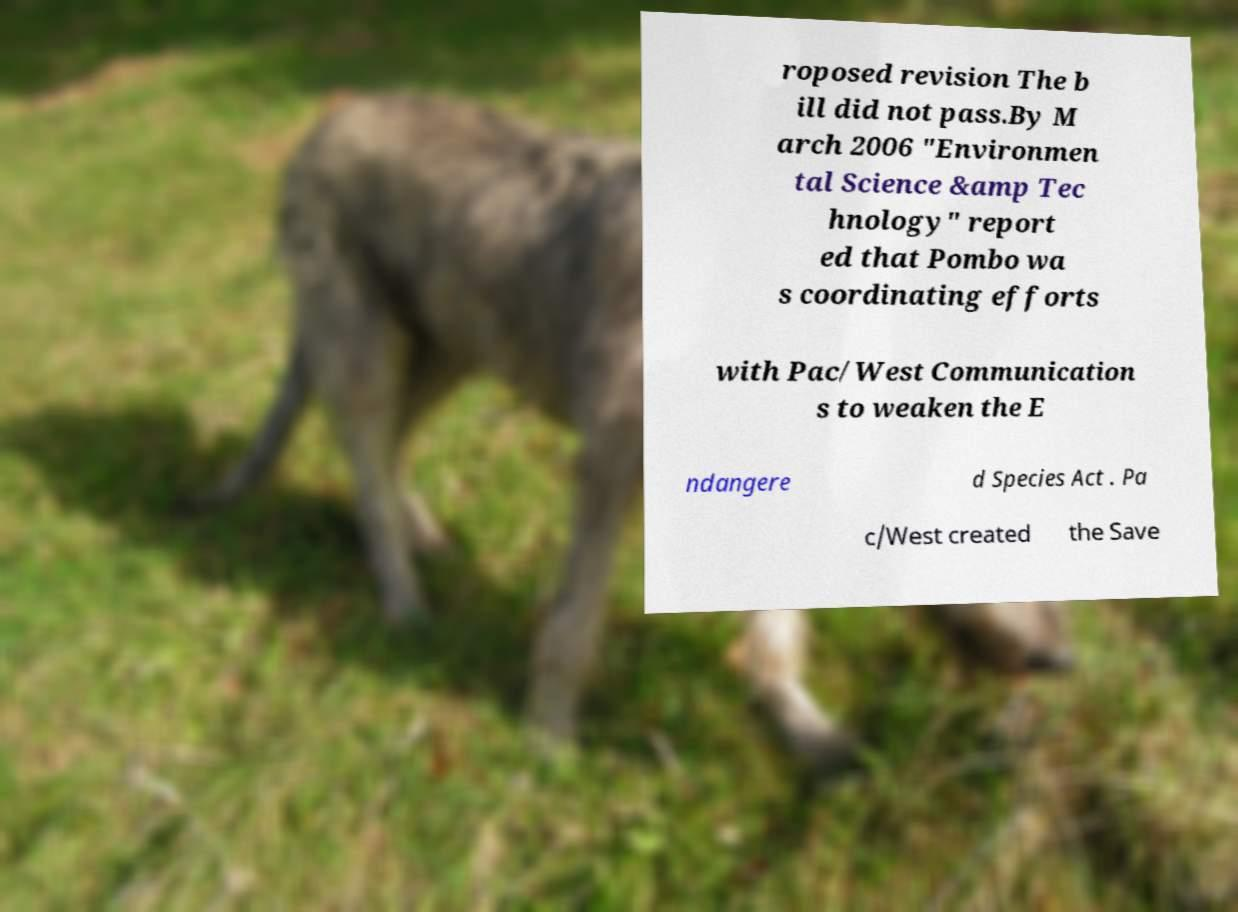What messages or text are displayed in this image? I need them in a readable, typed format. roposed revision The b ill did not pass.By M arch 2006 "Environmen tal Science &amp Tec hnology" report ed that Pombo wa s coordinating efforts with Pac/West Communication s to weaken the E ndangere d Species Act . Pa c/West created the Save 